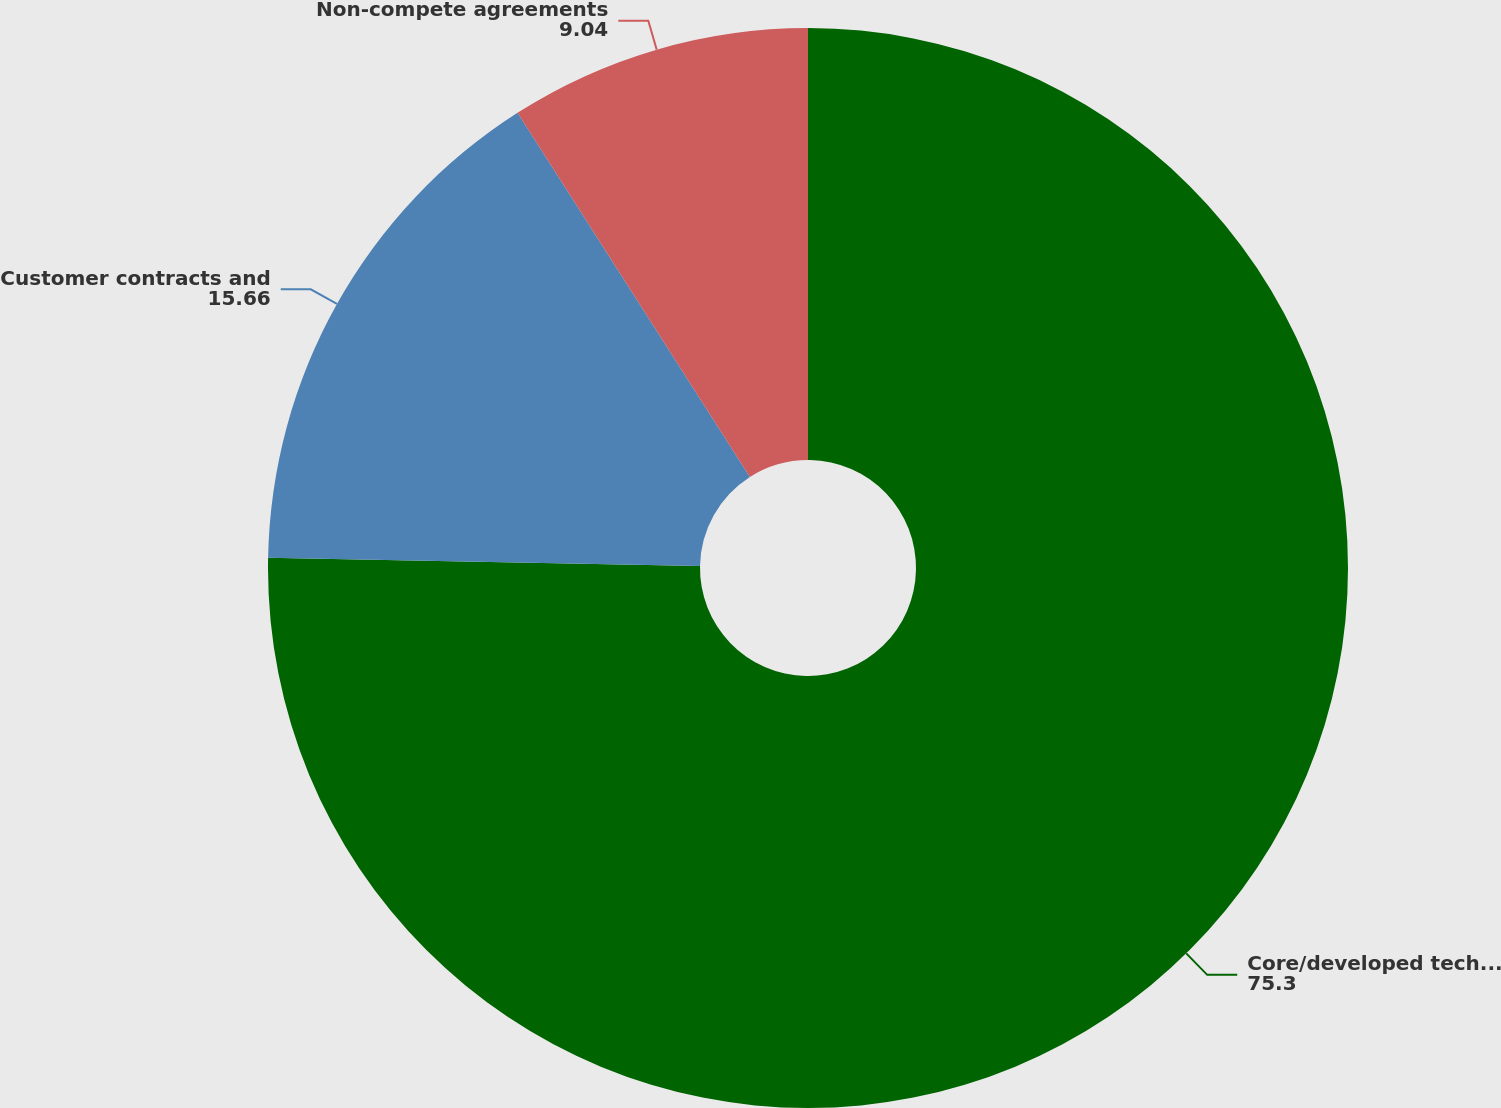<chart> <loc_0><loc_0><loc_500><loc_500><pie_chart><fcel>Core/developed technology<fcel>Customer contracts and<fcel>Non-compete agreements<nl><fcel>75.3%<fcel>15.66%<fcel>9.04%<nl></chart> 